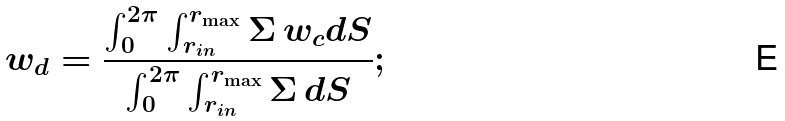<formula> <loc_0><loc_0><loc_500><loc_500>w _ { d } = \frac { \int _ { 0 } ^ { 2 \pi } \int _ { r _ { i n } } ^ { r _ { \max } } \Sigma \, w _ { c } d S } { \int _ { 0 } ^ { 2 \pi } \int _ { r _ { i n } } ^ { r _ { \max } } \Sigma \, d S } ;</formula> 